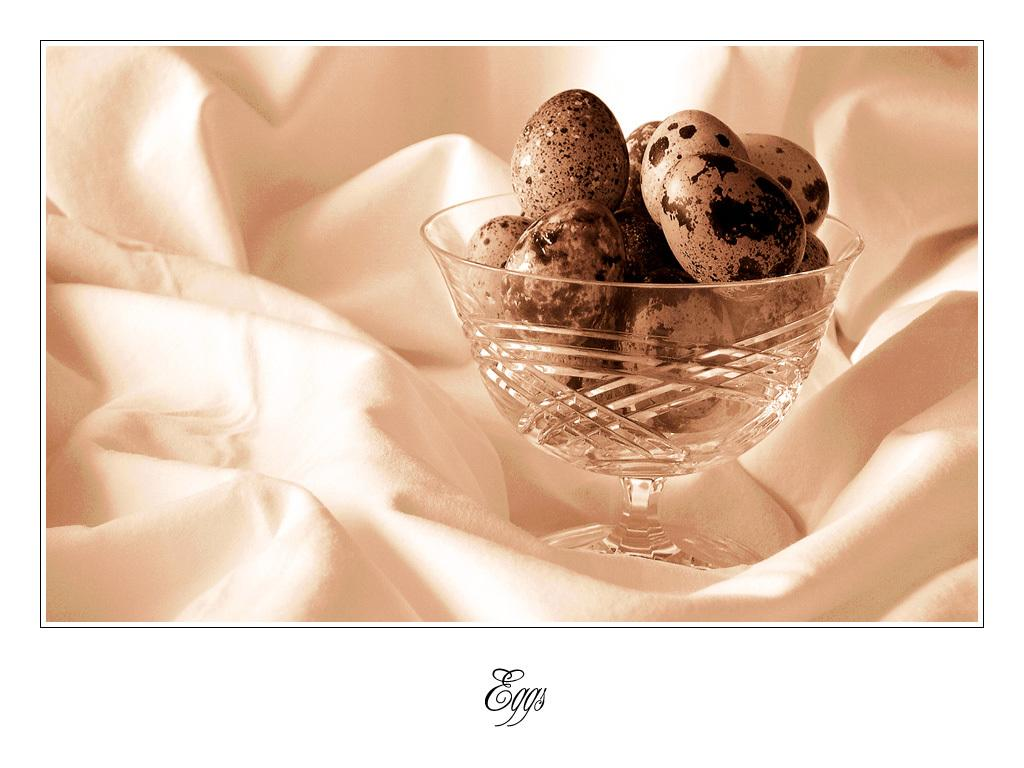What is in the bowl that is visible in the image? There are eggs in the bowl. Where is the bowl located in the image? The bowl is placed on a white cloth. What can be seen at the bottom of the image? There is text written at the bottom of the image. What type of sticks can be seen in the image? There are no sticks present in the image. What color is the ink used for the text at the bottom of the image? There is no mention of ink or its color in the provided facts, as the focus is on the bowl, eggs, and the white cloth. 